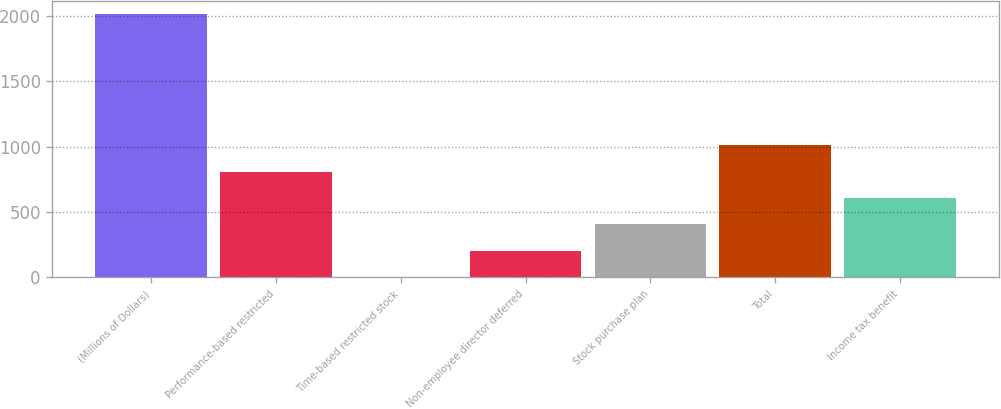Convert chart to OTSL. <chart><loc_0><loc_0><loc_500><loc_500><bar_chart><fcel>(Millions of Dollars)<fcel>Performance-based restricted<fcel>Time-based restricted stock<fcel>Non-employee director deferred<fcel>Stock purchase plan<fcel>Total<fcel>Income tax benefit<nl><fcel>2017<fcel>808<fcel>2<fcel>203.5<fcel>405<fcel>1009.5<fcel>606.5<nl></chart> 